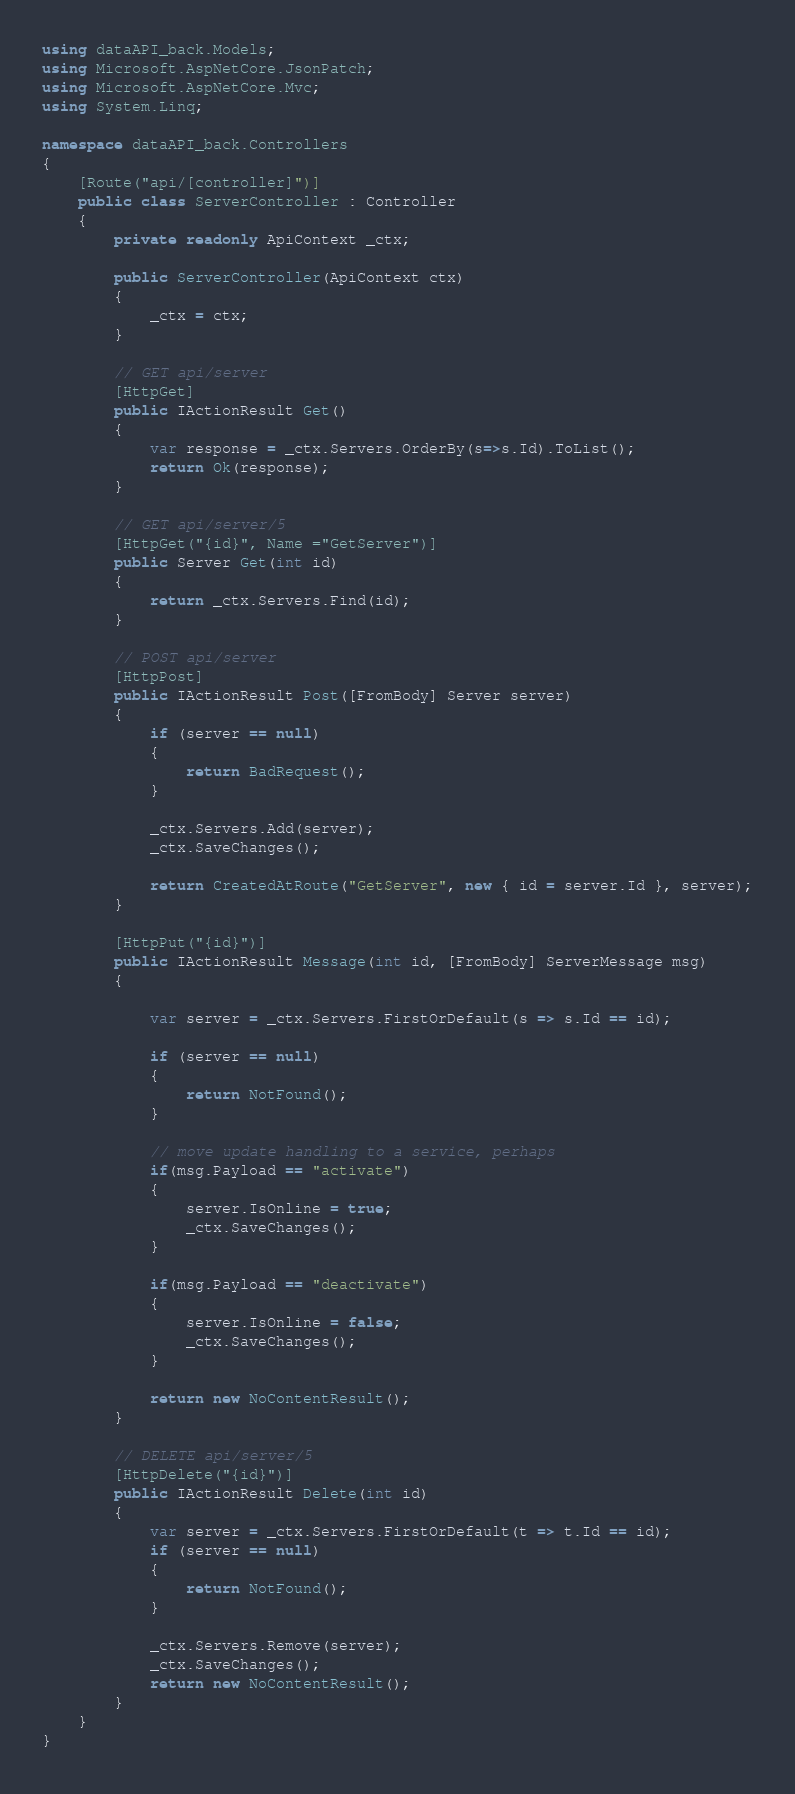Convert code to text. <code><loc_0><loc_0><loc_500><loc_500><_C#_>using dataAPI_back.Models;
using Microsoft.AspNetCore.JsonPatch;
using Microsoft.AspNetCore.Mvc;
using System.Linq;

namespace dataAPI_back.Controllers
{
    [Route("api/[controller]")]
    public class ServerController : Controller
    {
        private readonly ApiContext _ctx;

        public ServerController(ApiContext ctx)
        {
            _ctx = ctx;
        }

        // GET api/server
        [HttpGet]
        public IActionResult Get()
        {
            var response = _ctx.Servers.OrderBy(s=>s.Id).ToList(); 
            return Ok(response);
        }

        // GET api/server/5
        [HttpGet("{id}", Name ="GetServer")]
        public Server Get(int id)
        {
            return _ctx.Servers.Find(id);
        }

        // POST api/server
        [HttpPost]
        public IActionResult Post([FromBody] Server server)
        {
            if (server == null)
            {
                return BadRequest();
            }

            _ctx.Servers.Add(server);
            _ctx.SaveChanges();

            return CreatedAtRoute("GetServer", new { id = server.Id }, server);
        }

        [HttpPut("{id}")]
        public IActionResult Message(int id, [FromBody] ServerMessage msg)
        {

            var server = _ctx.Servers.FirstOrDefault(s => s.Id == id);

            if (server == null)
            {
                return NotFound();
            }

            // move update handling to a service, perhaps
            if(msg.Payload == "activate")
            {
                server.IsOnline = true;
                _ctx.SaveChanges();
            }

            if(msg.Payload == "deactivate")
            {
                server.IsOnline = false;
                _ctx.SaveChanges();
            }

            return new NoContentResult();
        }

        // DELETE api/server/5
        [HttpDelete("{id}")]
        public IActionResult Delete(int id)
        {
            var server = _ctx.Servers.FirstOrDefault(t => t.Id == id);
            if (server == null)
            {
                return NotFound();
            }

            _ctx.Servers.Remove(server);
            _ctx.SaveChanges();
            return new NoContentResult();
        }
    }
}
</code> 